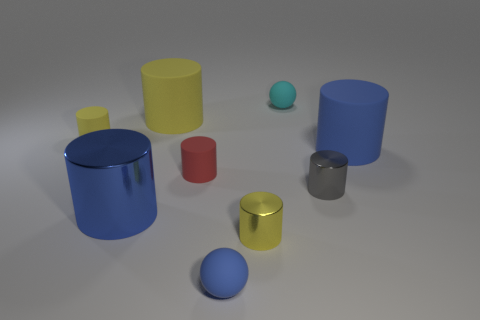Which objects in the image have the most vibrant colors? The blue cylinder and the red cylinder have the most vibrant colors, exhibiting bright and saturated hues that draw the eye. 